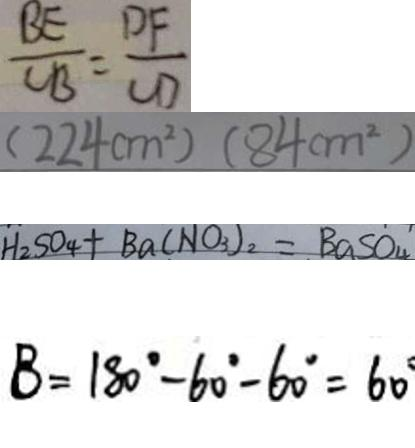Convert formula to latex. <formula><loc_0><loc_0><loc_500><loc_500>\frac { B E } { C B } = \frac { D F } { C D } 
 ( 2 2 4 c m ^ { 2 } ) ( 8 4 c m ^ { 2 } ) 
 H _ { 2 } S O _ { 4 } + B a ( N O _ { 3 } ) _ { 2 } = B a S O _ { 4 } 
 B = 1 8 0 ^ { \circ } - 6 0 ^ { \circ } - 6 0 ^ { \circ } = 6 0 ^ { \circ }</formula> 